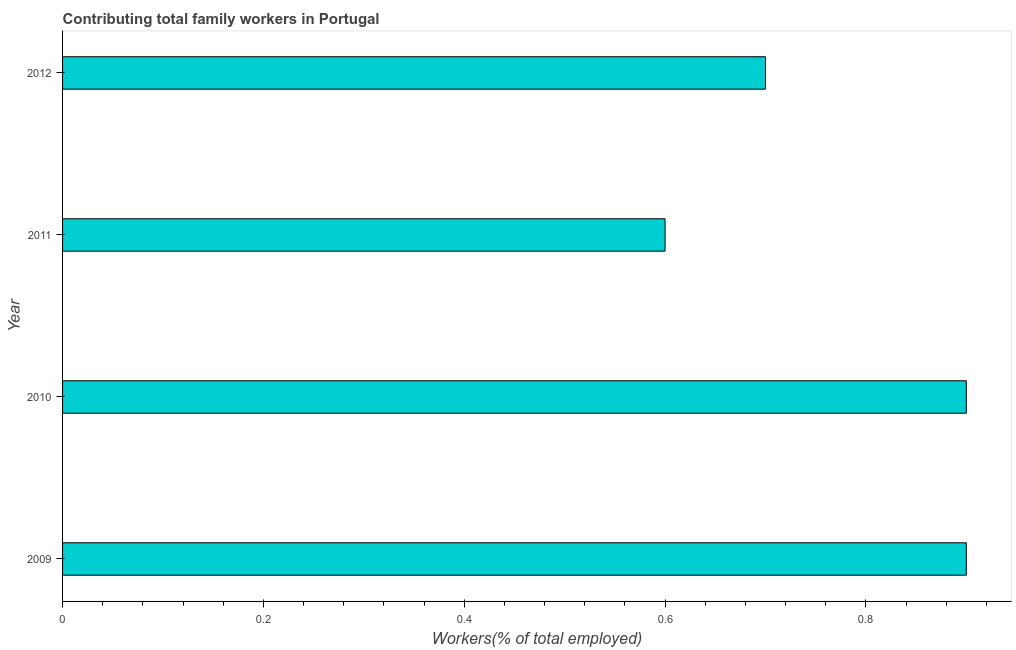Does the graph contain any zero values?
Keep it short and to the point. No. Does the graph contain grids?
Keep it short and to the point. No. What is the title of the graph?
Your answer should be compact. Contributing total family workers in Portugal. What is the label or title of the X-axis?
Offer a terse response. Workers(% of total employed). What is the contributing family workers in 2009?
Your answer should be compact. 0.9. Across all years, what is the maximum contributing family workers?
Ensure brevity in your answer.  0.9. Across all years, what is the minimum contributing family workers?
Provide a succinct answer. 0.6. In which year was the contributing family workers maximum?
Provide a short and direct response. 2009. In which year was the contributing family workers minimum?
Offer a terse response. 2011. What is the sum of the contributing family workers?
Offer a terse response. 3.1. What is the average contributing family workers per year?
Provide a succinct answer. 0.78. What is the median contributing family workers?
Your answer should be very brief. 0.8. In how many years, is the contributing family workers greater than 0.64 %?
Offer a terse response. 3. Do a majority of the years between 2009 and 2012 (inclusive) have contributing family workers greater than 0.6 %?
Your answer should be very brief. Yes. What is the ratio of the contributing family workers in 2010 to that in 2012?
Your answer should be compact. 1.29. Is the difference between the contributing family workers in 2010 and 2012 greater than the difference between any two years?
Your answer should be very brief. No. What is the difference between the highest and the lowest contributing family workers?
Your response must be concise. 0.3. In how many years, is the contributing family workers greater than the average contributing family workers taken over all years?
Keep it short and to the point. 2. Are all the bars in the graph horizontal?
Offer a very short reply. Yes. How many years are there in the graph?
Your response must be concise. 4. What is the difference between two consecutive major ticks on the X-axis?
Your answer should be very brief. 0.2. What is the Workers(% of total employed) in 2009?
Your response must be concise. 0.9. What is the Workers(% of total employed) of 2010?
Your answer should be very brief. 0.9. What is the Workers(% of total employed) of 2011?
Provide a succinct answer. 0.6. What is the Workers(% of total employed) of 2012?
Make the answer very short. 0.7. What is the difference between the Workers(% of total employed) in 2009 and 2011?
Give a very brief answer. 0.3. What is the difference between the Workers(% of total employed) in 2009 and 2012?
Offer a terse response. 0.2. What is the difference between the Workers(% of total employed) in 2010 and 2011?
Your answer should be very brief. 0.3. What is the ratio of the Workers(% of total employed) in 2009 to that in 2010?
Keep it short and to the point. 1. What is the ratio of the Workers(% of total employed) in 2009 to that in 2012?
Keep it short and to the point. 1.29. What is the ratio of the Workers(% of total employed) in 2010 to that in 2012?
Provide a succinct answer. 1.29. What is the ratio of the Workers(% of total employed) in 2011 to that in 2012?
Ensure brevity in your answer.  0.86. 